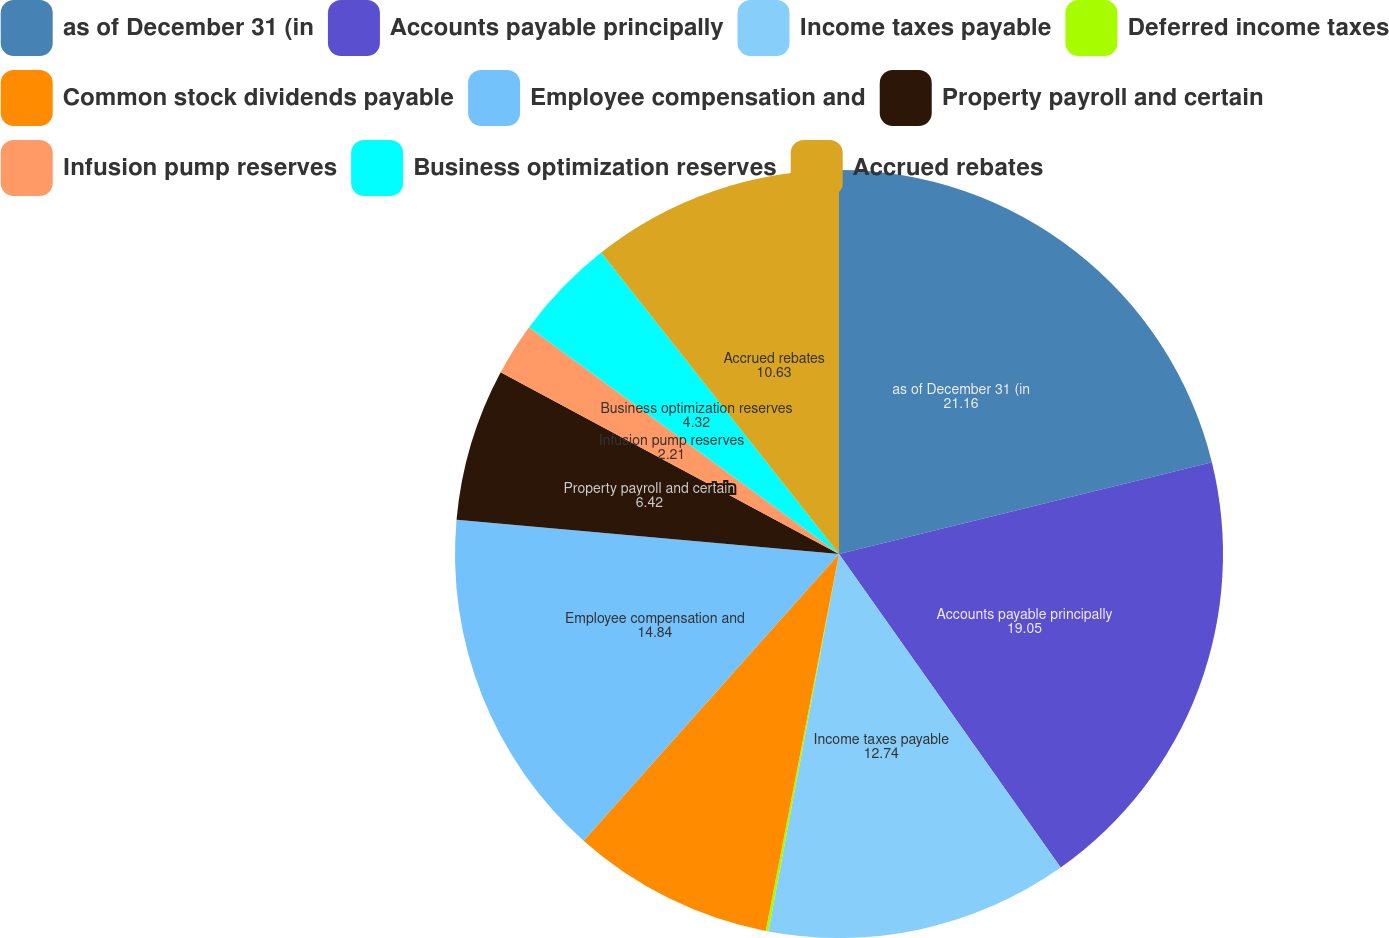Convert chart. <chart><loc_0><loc_0><loc_500><loc_500><pie_chart><fcel>as of December 31 (in<fcel>Accounts payable principally<fcel>Income taxes payable<fcel>Deferred income taxes<fcel>Common stock dividends payable<fcel>Employee compensation and<fcel>Property payroll and certain<fcel>Infusion pump reserves<fcel>Business optimization reserves<fcel>Accrued rebates<nl><fcel>21.16%<fcel>19.05%<fcel>12.74%<fcel>0.11%<fcel>8.53%<fcel>14.84%<fcel>6.42%<fcel>2.21%<fcel>4.32%<fcel>10.63%<nl></chart> 